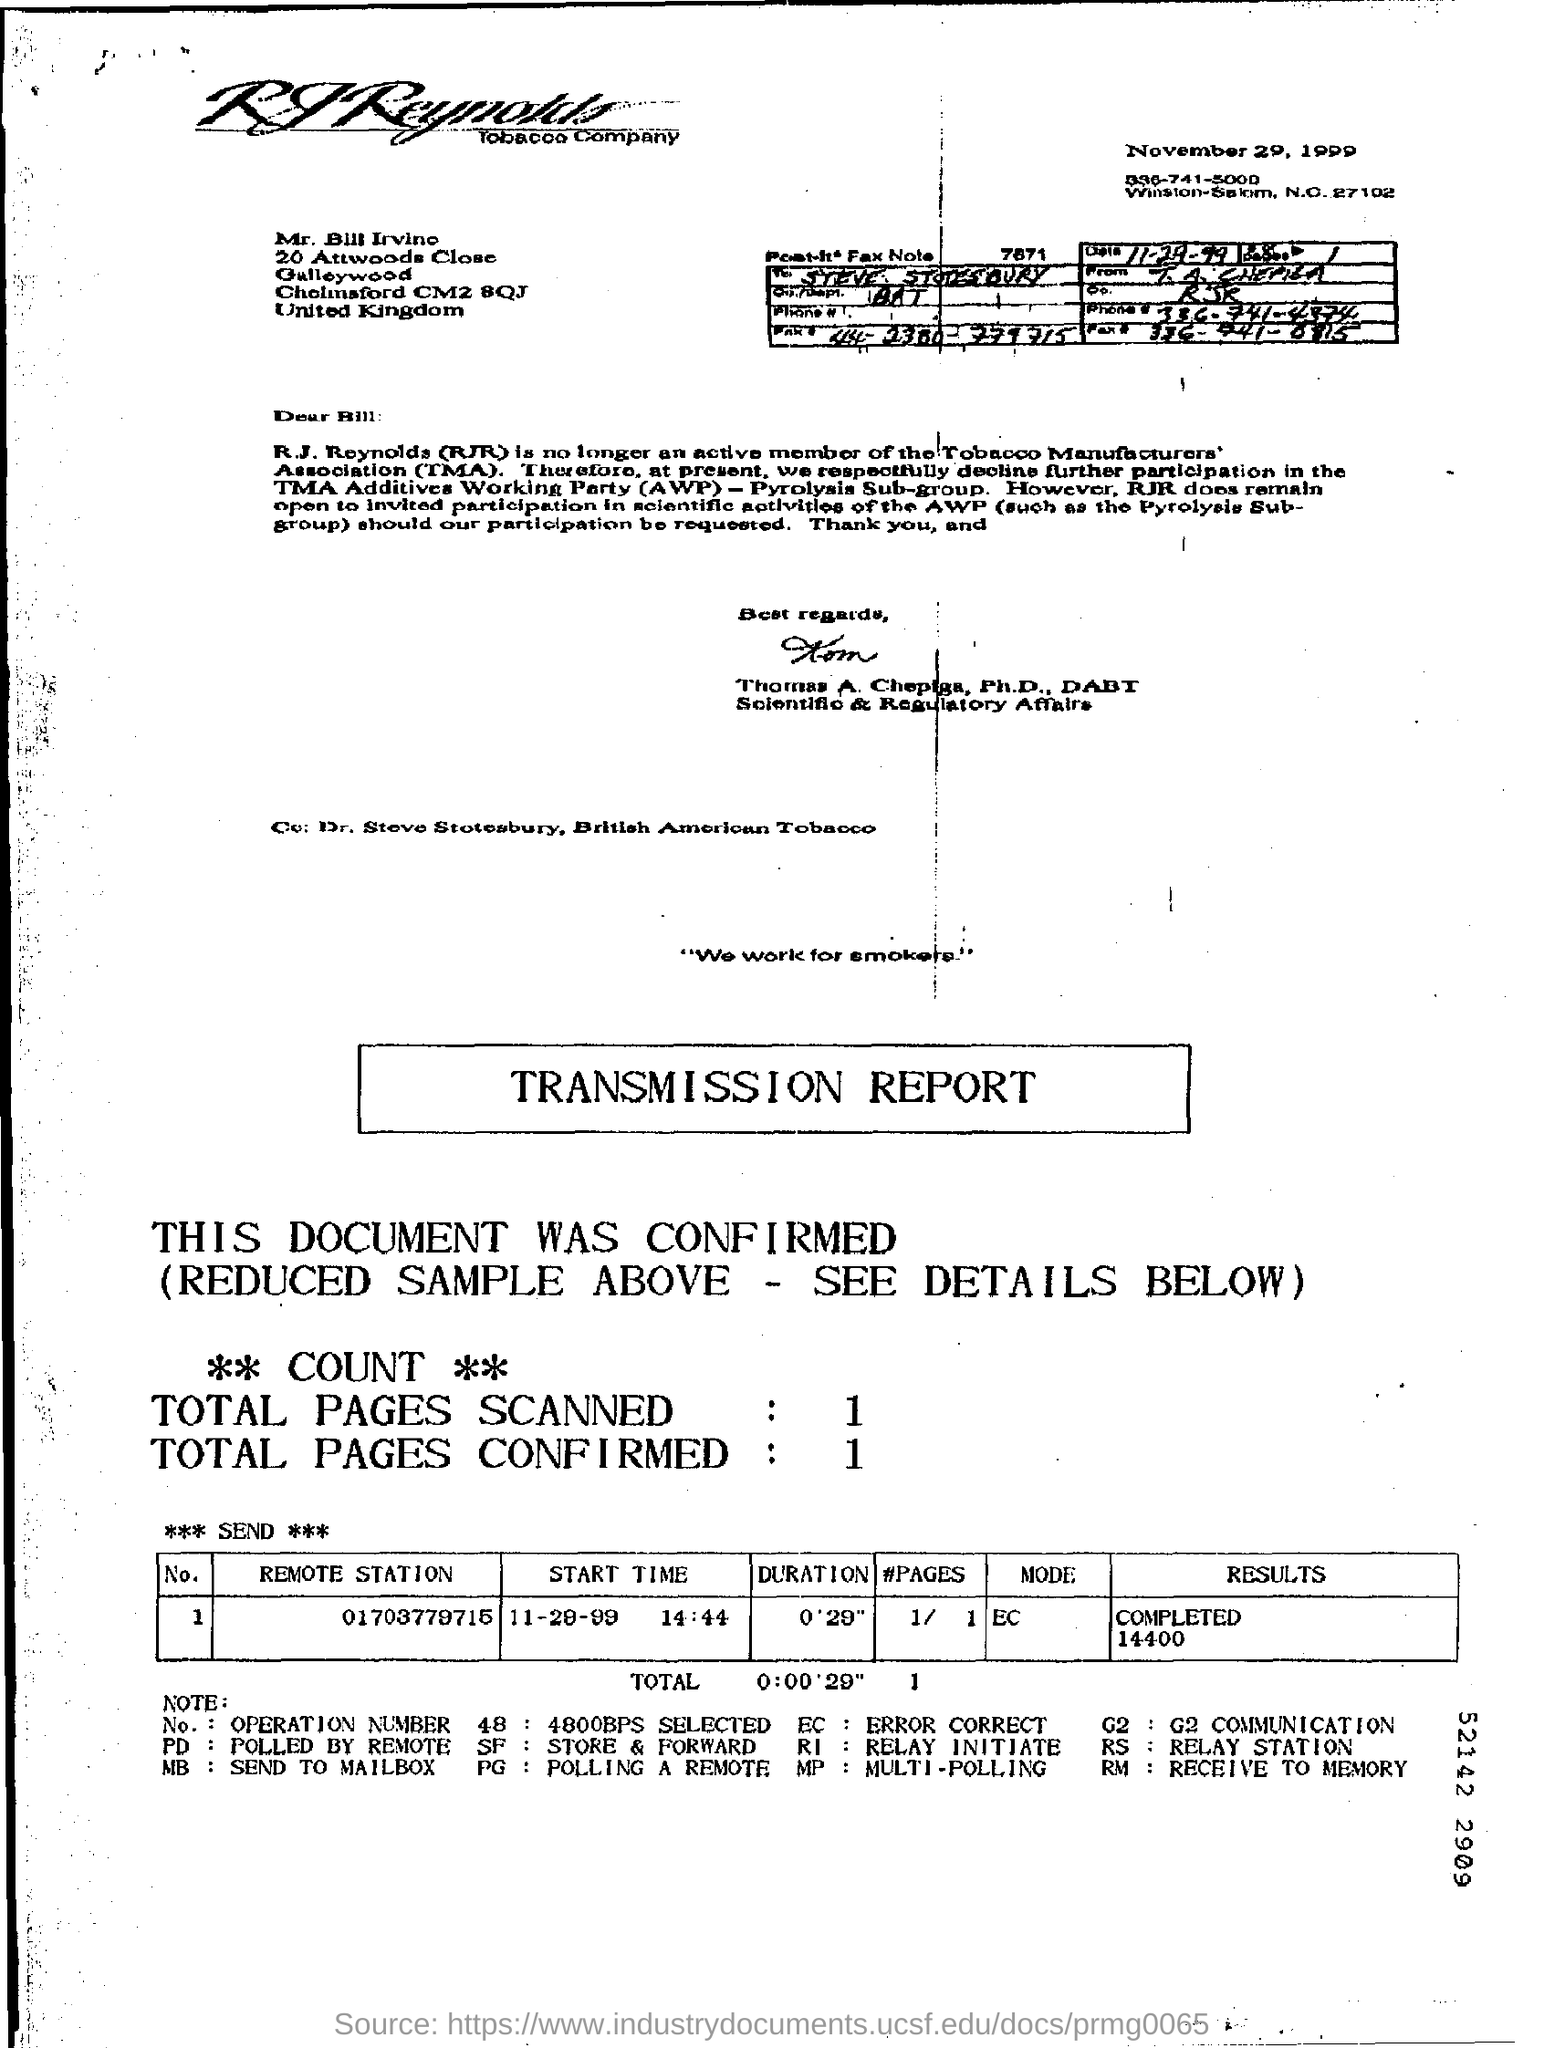What kind of document is this?
Make the answer very short. TRANSMISSION REPORT. What is the date mentioned at the top?
Make the answer very short. November 29, 1999. 